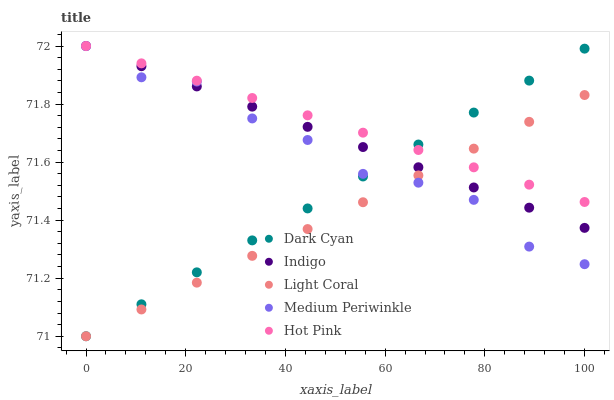Does Light Coral have the minimum area under the curve?
Answer yes or no. Yes. Does Hot Pink have the maximum area under the curve?
Answer yes or no. Yes. Does Hot Pink have the minimum area under the curve?
Answer yes or no. No. Does Light Coral have the maximum area under the curve?
Answer yes or no. No. Is Indigo the smoothest?
Answer yes or no. Yes. Is Medium Periwinkle the roughest?
Answer yes or no. Yes. Is Light Coral the smoothest?
Answer yes or no. No. Is Light Coral the roughest?
Answer yes or no. No. Does Dark Cyan have the lowest value?
Answer yes or no. Yes. Does Hot Pink have the lowest value?
Answer yes or no. No. Does Indigo have the highest value?
Answer yes or no. Yes. Does Light Coral have the highest value?
Answer yes or no. No. Is Medium Periwinkle less than Hot Pink?
Answer yes or no. Yes. Is Hot Pink greater than Medium Periwinkle?
Answer yes or no. Yes. Does Dark Cyan intersect Hot Pink?
Answer yes or no. Yes. Is Dark Cyan less than Hot Pink?
Answer yes or no. No. Is Dark Cyan greater than Hot Pink?
Answer yes or no. No. Does Medium Periwinkle intersect Hot Pink?
Answer yes or no. No. 